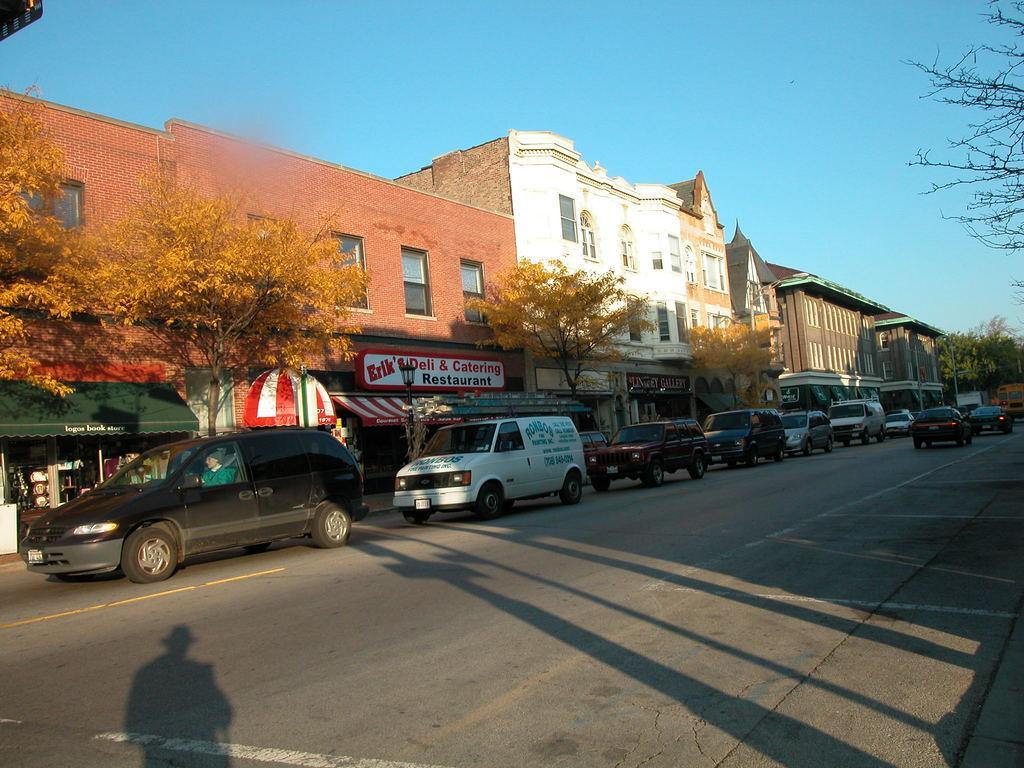Describe this image in one or two sentences. There is a road. On the road there are vehicles. In the back there are many buildings with windows. Also there are trees and something is written on the building. In the background there is sky. And on the left side we can see a shadow of a person. 